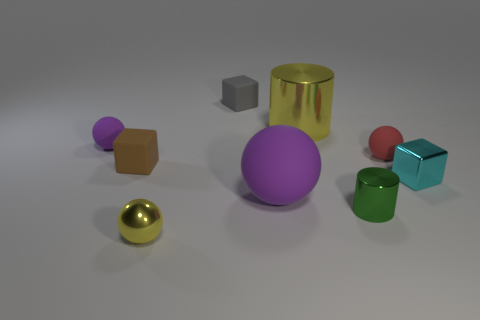Add 1 tiny green metal cylinders. How many objects exist? 10 Subtract all cylinders. How many objects are left? 7 Subtract all small cyan rubber cylinders. Subtract all red matte spheres. How many objects are left? 8 Add 6 metal cylinders. How many metal cylinders are left? 8 Add 8 big green shiny cylinders. How many big green shiny cylinders exist? 8 Subtract 1 gray cubes. How many objects are left? 8 